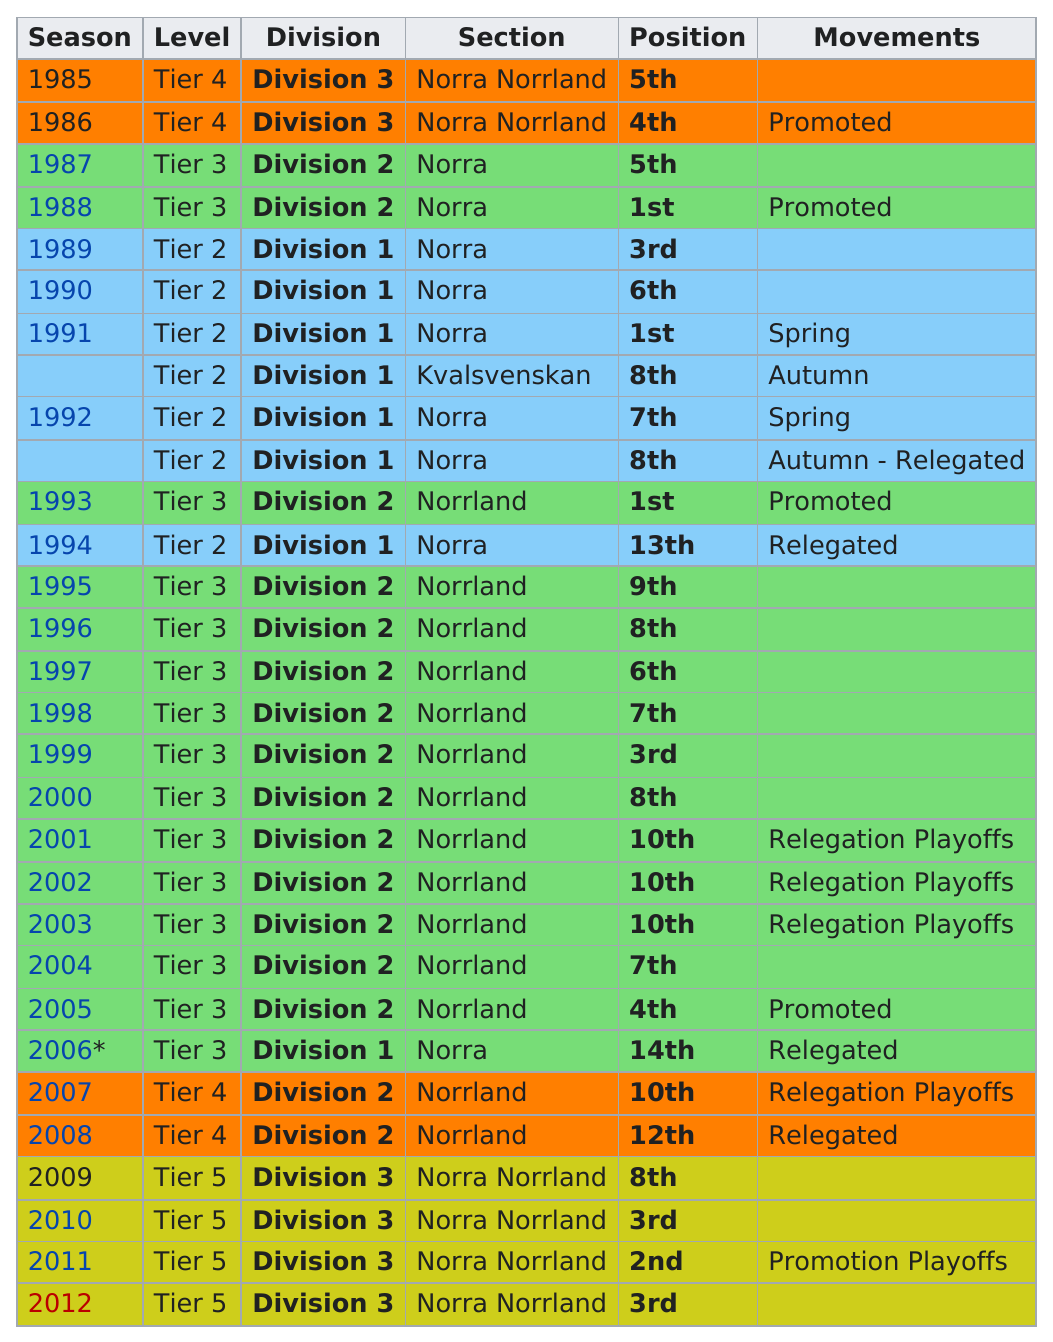Draw attention to some important aspects in this diagram. Division 3 has the least entries among all divisions. The team last ranked first in 1993. The first season was in 1985. The last season was in 2012. Our team's historical lowest position is 13th. 